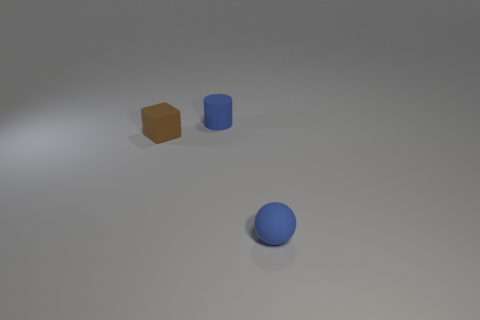Subtract all brown cylinders. Subtract all gray cubes. How many cylinders are left? 1 Add 3 tiny rubber cubes. How many objects exist? 6 Subtract all spheres. How many objects are left? 2 Add 3 big green spheres. How many big green spheres exist? 3 Subtract 0 purple spheres. How many objects are left? 3 Subtract all gray blocks. Subtract all brown things. How many objects are left? 2 Add 3 tiny matte spheres. How many tiny matte spheres are left? 4 